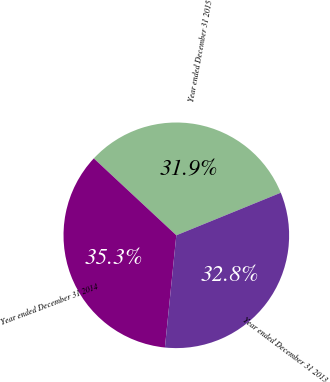Convert chart. <chart><loc_0><loc_0><loc_500><loc_500><pie_chart><fcel>Year ended December 31 2015<fcel>Year ended December 31 2014<fcel>Year ended December 31 2013<nl><fcel>31.9%<fcel>35.32%<fcel>32.77%<nl></chart> 